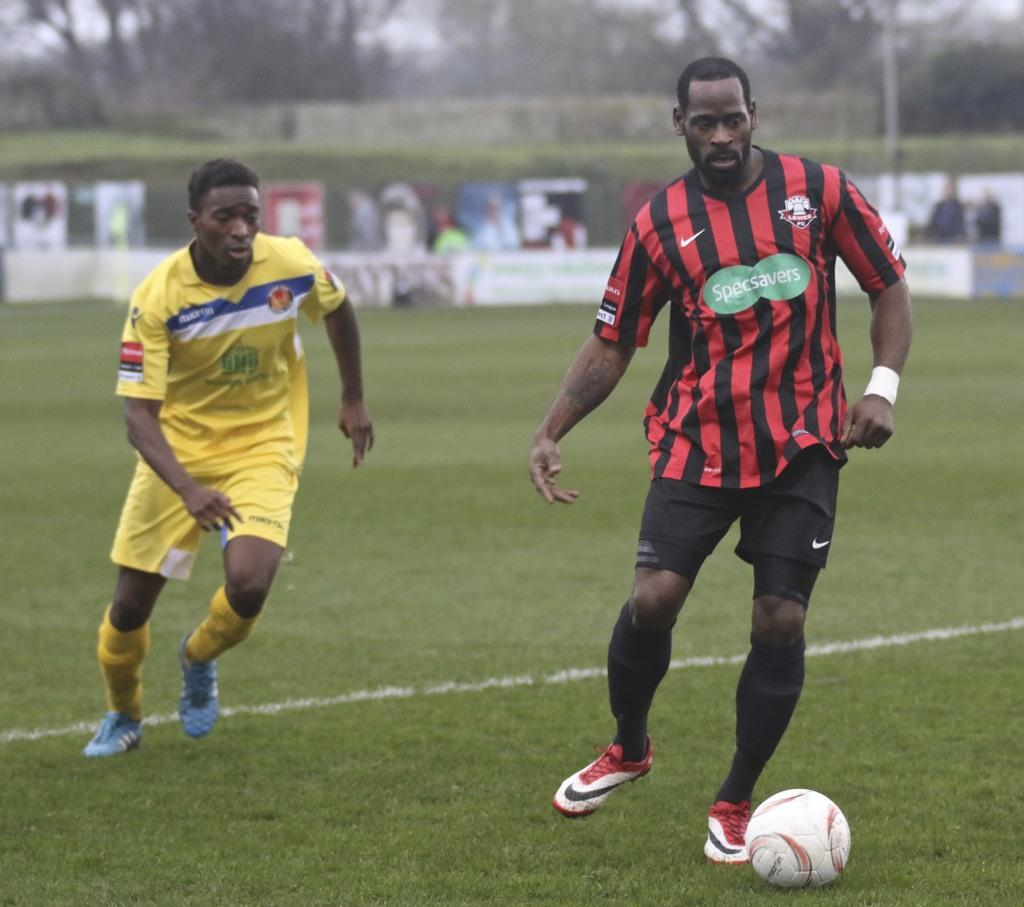How many players are on the ground in the image? There are two players on the ground in the image. What object is visible with the players? There is a ball visible in the image. What can be seen in the background of the image? There are hoardings and trees in the background, as well as some persons. What type of ghost can be seen interacting with the players in the image? There is no ghost present in the image; it features two players on the ground with a ball. What is the purpose of the heart in the image? There is no heart present in the image; it features two players on the ground with a ball and various elements in the background. 